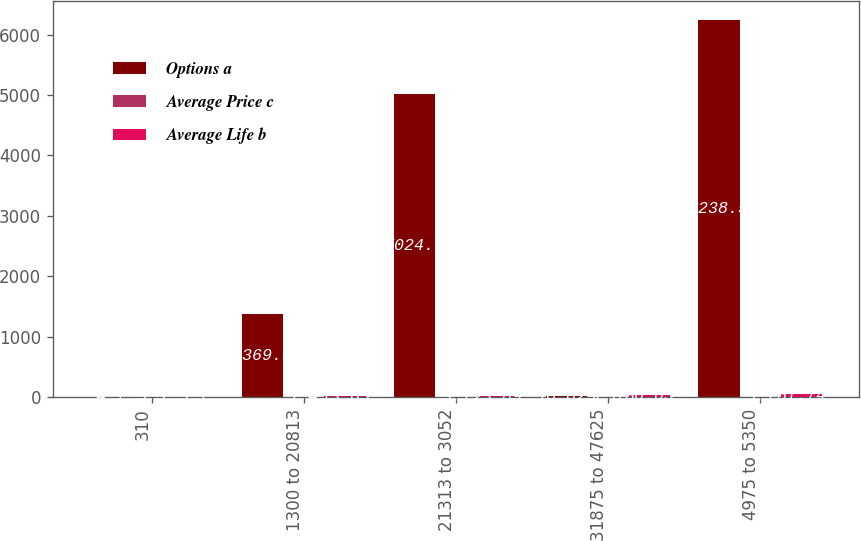<chart> <loc_0><loc_0><loc_500><loc_500><stacked_bar_chart><ecel><fcel>310<fcel>1300 to 20813<fcel>21313 to 3052<fcel>31875 to 47625<fcel>4975 to 5350<nl><fcel>Options a<fcel>4.1<fcel>1369.3<fcel>5024.7<fcel>10.025<fcel>6238.5<nl><fcel>Average Price c<fcel>3.3<fcel>1.4<fcel>3.1<fcel>7<fcel>5.1<nl><fcel>Average Life b<fcel>3.1<fcel>13.05<fcel>23.89<fcel>36.05<fcel>51.74<nl></chart> 